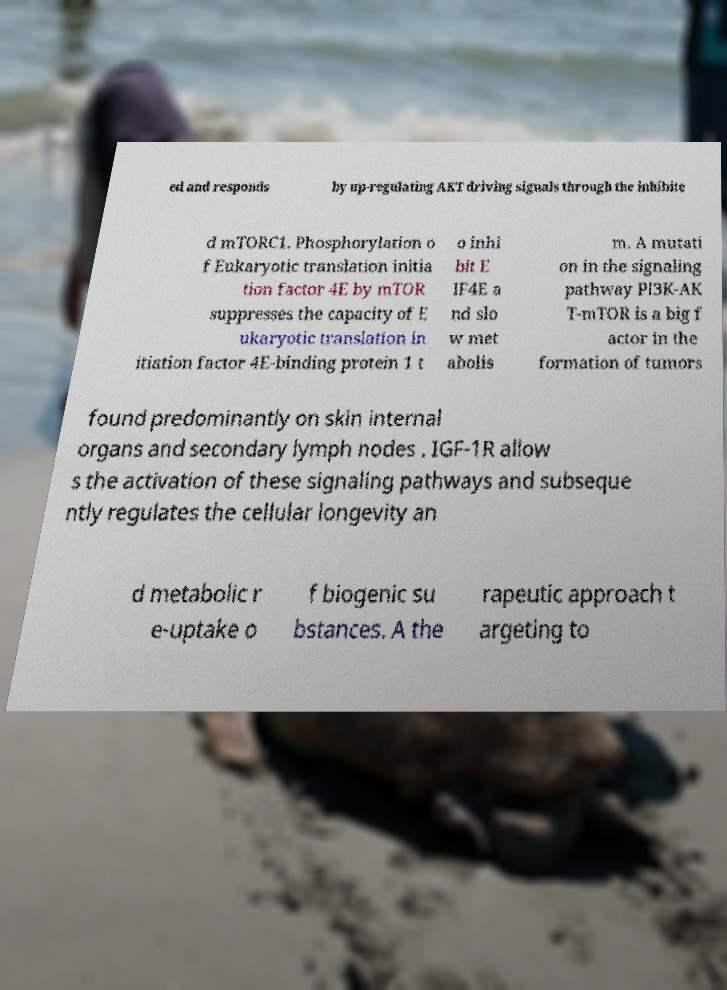There's text embedded in this image that I need extracted. Can you transcribe it verbatim? ed and responds by up-regulating AKT driving signals through the inhibite d mTORC1. Phosphorylation o f Eukaryotic translation initia tion factor 4E by mTOR suppresses the capacity of E ukaryotic translation in itiation factor 4E-binding protein 1 t o inhi bit E IF4E a nd slo w met abolis m. A mutati on in the signaling pathway PI3K-AK T-mTOR is a big f actor in the formation of tumors found predominantly on skin internal organs and secondary lymph nodes . IGF-1R allow s the activation of these signaling pathways and subseque ntly regulates the cellular longevity an d metabolic r e-uptake o f biogenic su bstances. A the rapeutic approach t argeting to 